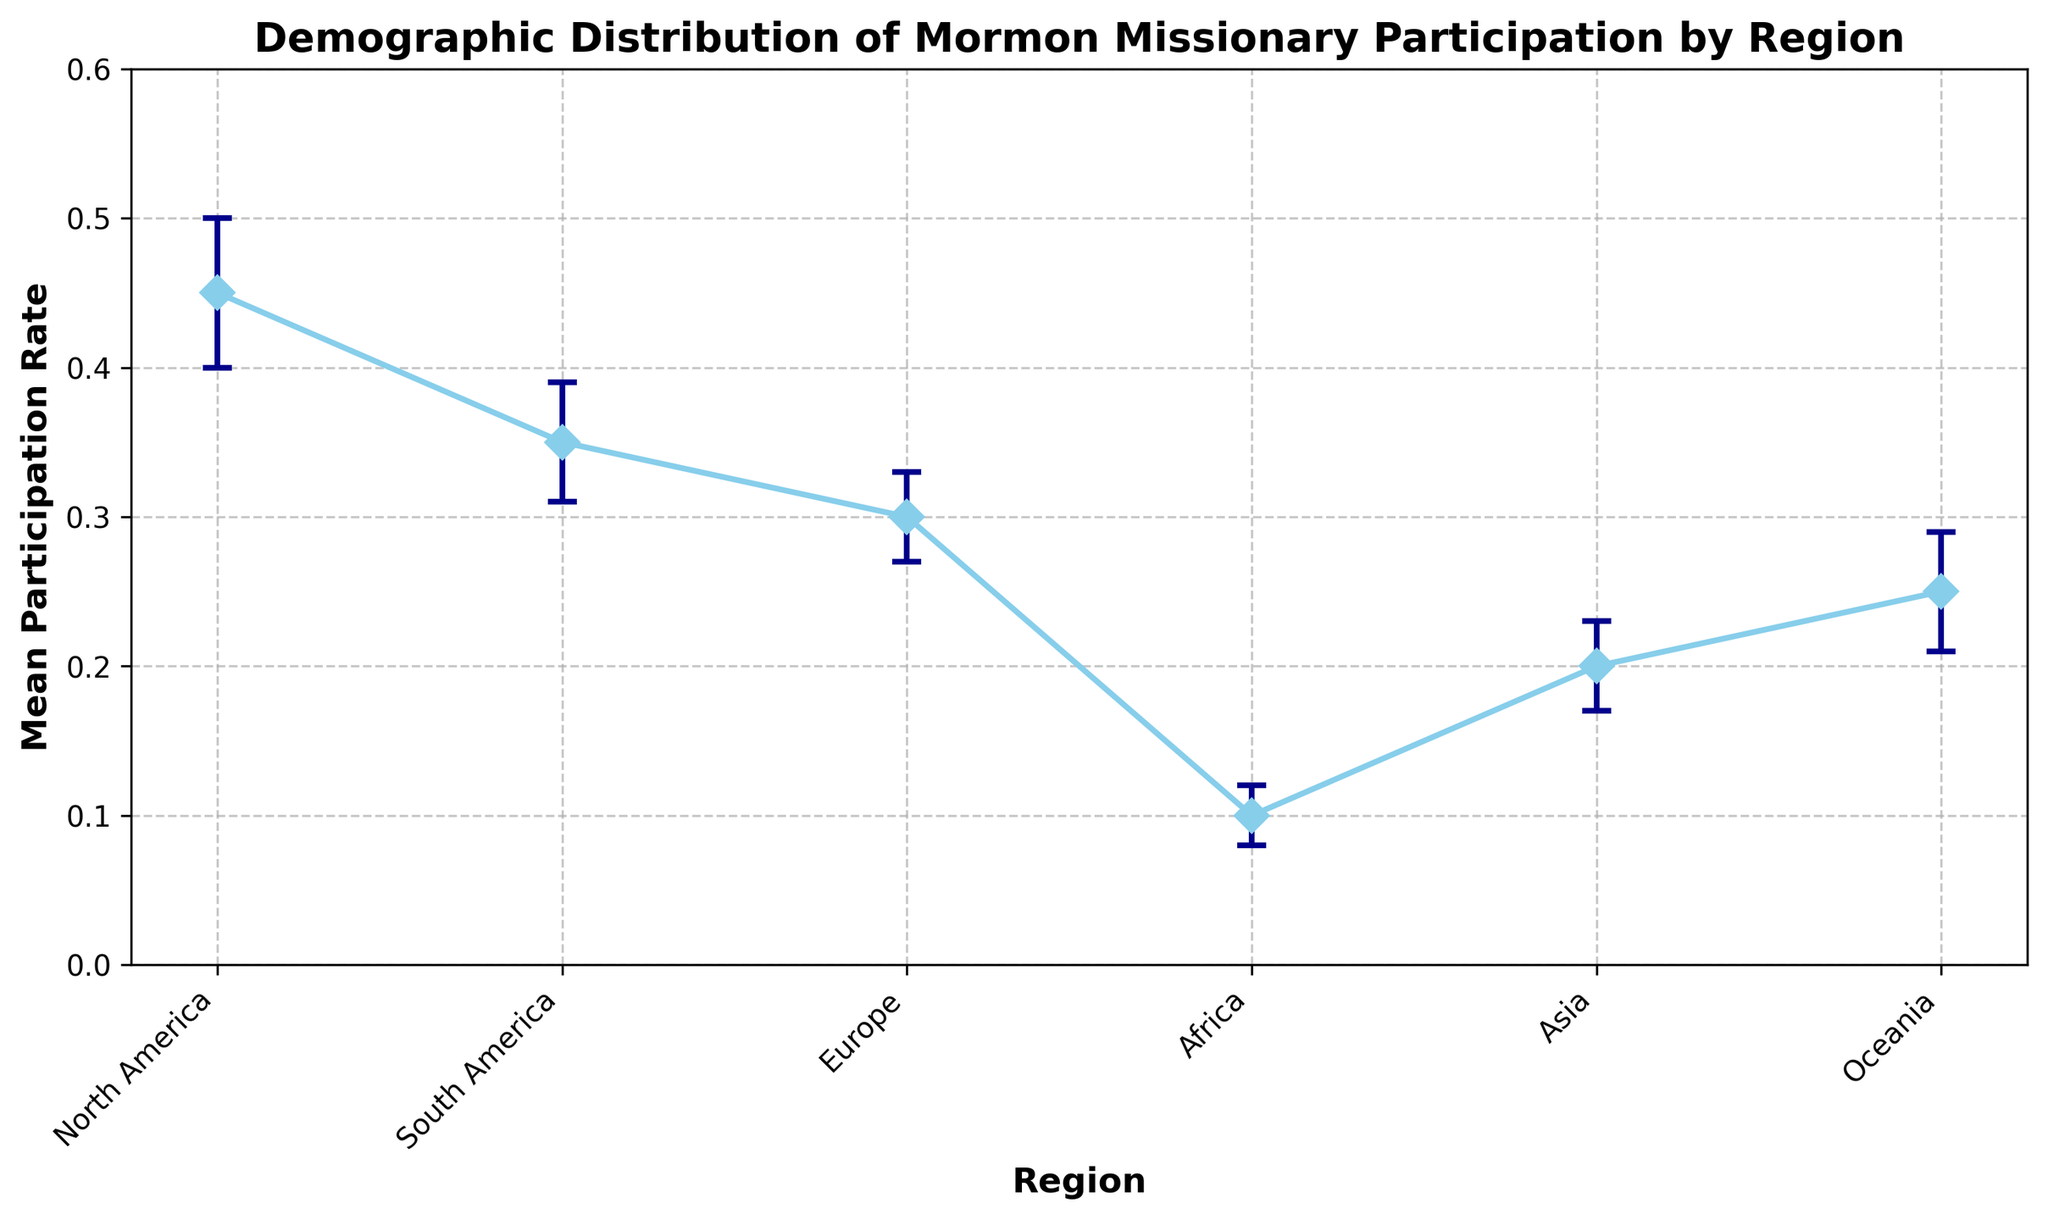What region has the highest mean participation rate in Mormon missionary activities? By looking at the height of the error bars and the data points along the y-axis on the figure, the North America region has the highest mean participation rate.
Answer: North America What is the difference in the mean participation rate between North America and Europe? By identifying the mean participation rates from the figure, North America has 0.45 and Europe has 0.30. The difference is 0.45 - 0.30 = 0.15.
Answer: 0.15 Which region has the lowest mean participation rate, and what is its value? By examining the error bars and the data points on the figure, the Africa region has the lowest mean participation rate of 0.10.
Answer: Africa, 0.10 If the participation rates for Asia and Oceania are combined, what would be the average mean participation rate? From the figure, the mean participation rates for Asia and Oceania are 0.20 and 0.25, respectively. The average is calculated as (0.20 + 0.25) / 2 = 0.225.
Answer: 0.225 How does the standard deviation compare between South America and Oceania? By looking at the length of the error bars on the figure, the standard deviation for South America is 0.04 and for Oceania is also 0.04, so they are equal.
Answer: Equal What is the range of the mean participation rates across all regions shown in the figure? By identifying the highest and lowest mean participation rates from the figure, the highest rate is in North America (0.45) and the lowest is in Africa (0.10). The range is 0.45 - 0.10 = 0.35.
Answer: 0.35 Which region's mean participation rate has the smallest error margin? By observing the lengths of the error bars, Europe has the shortest error bars, indicating the smallest standard deviation of 0.03.
Answer: Europe What is the collective sum of the mean participation rates for all regions? By summing the mean participation rates from the figure: 0.45 (North America) + 0.35 (South America) + 0.30 (Europe) + 0.10 (Africa) + 0.20 (Asia) + 0.25 (Oceania) = 1.65.
Answer: 1.65 What is the visual characteristic that distinguishes the error margins in the figure? The error margins are represented by vertical lines with caps extending above and below each data point with differing heights corresponding to their standard deviation.
Answer: Vertical lines with caps What can be visually identified about the participation rates in Asia compared to South America? By observing the figure, Asia has a lower mean participation rate (0.20) compared to South America (0.35). Additionally, the error margin for Asia is slightly larger than that for South America.
Answer: Lower, larger error margin 